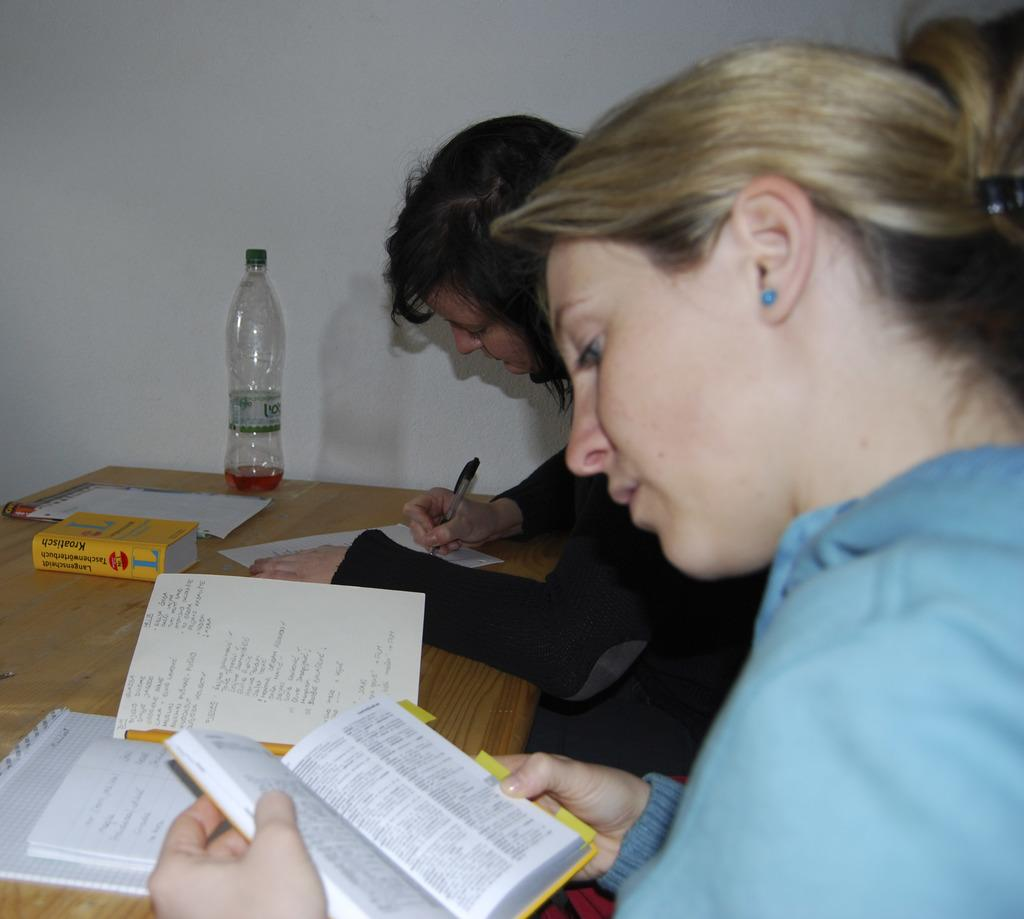<image>
Render a clear and concise summary of the photo. Two women sitting at a table while reading Kroatisch. 